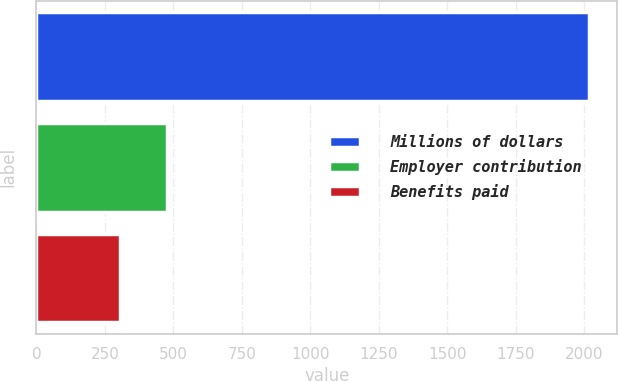<chart> <loc_0><loc_0><loc_500><loc_500><bar_chart><fcel>Millions of dollars<fcel>Employer contribution<fcel>Benefits paid<nl><fcel>2018<fcel>476.3<fcel>305<nl></chart> 